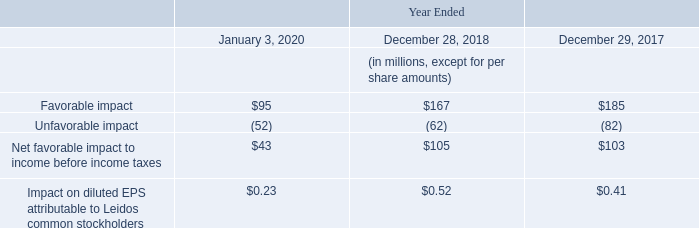Changes in Estimates on Contracts
Changes in estimates related to contracts accounted for using the cost-to-cost method of accounting are recognized in the period in which such changes are made for the inception-to-date effect of the changes, with the exception of contracts acquired through a business combination, where the adjustment is made for the period commencing from the date of acquisition.
Changes in estimates on contracts for the periods presented were as follows:
The impact on diluted EPS attributable to Leidos common stockholders is calculated using the Company's statutory tax rate.
What was the Unfavorable impact in 2018?
Answer scale should be: million. (62). What was the Favorable impact in 2020, 2018 and 2017 respectively?
Answer scale should be: million. $95, $167, $185. What was the Unfavorable impact in 2020?
Answer scale should be: million. (52). In which period was Favorable impact more than 100 million? Locate and analyze favorable impact in row 5
answer: 2018, 2017. What is the average Unfavorable impact in 2018 and 2017?
Answer scale should be: million. -(62 + 82) / 2
Answer: -72. What is the change in the Net favorable impact to income before income taxes from 2018 to 2017?
Answer scale should be: million. 105 - 103
Answer: 2. 